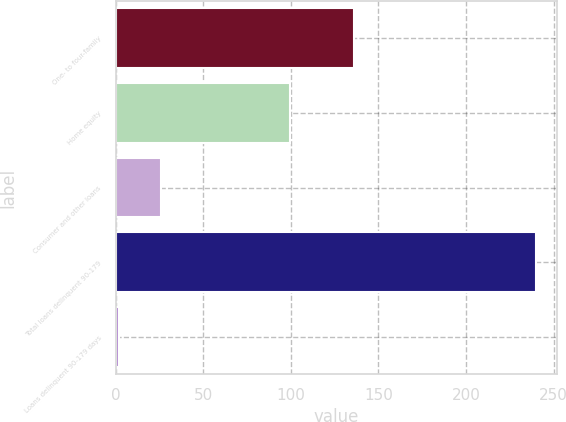Convert chart to OTSL. <chart><loc_0><loc_0><loc_500><loc_500><bar_chart><fcel>One- to four-family<fcel>Home equity<fcel>Consumer and other loans<fcel>Total loans delinquent 90-179<fcel>Loans delinquent 90-179 days<nl><fcel>136.2<fcel>99.7<fcel>25.64<fcel>240<fcel>1.82<nl></chart> 